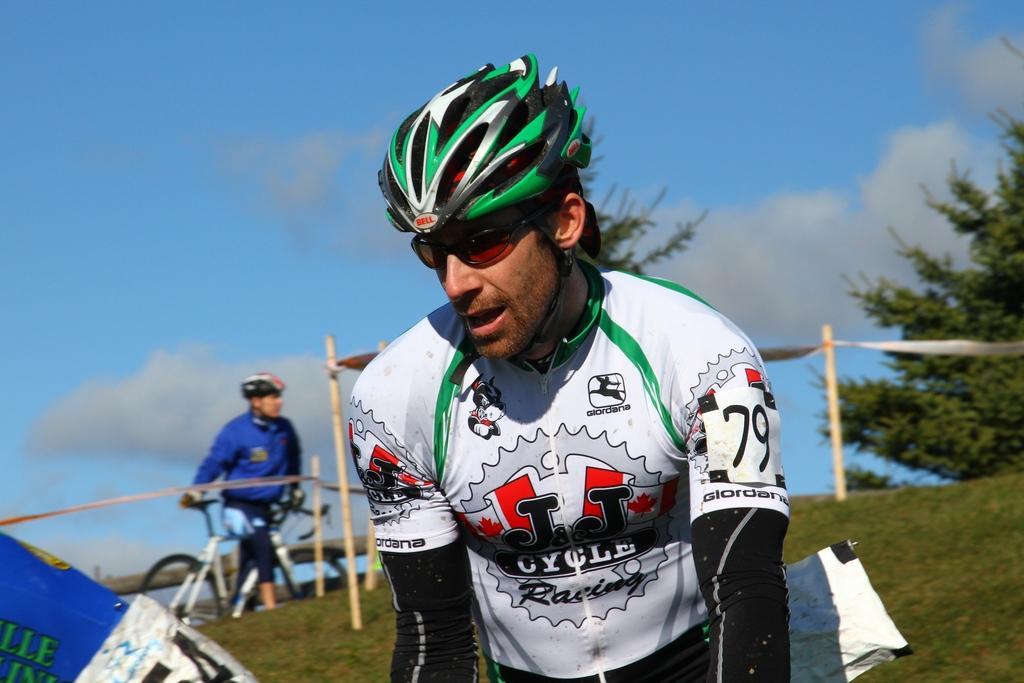How would you summarize this image in a sentence or two? In this picture I can observe a man in the middle of the picture. Man is wearing spectacles and helmet on his head. In the background there are trees and some clouds in the sky. 